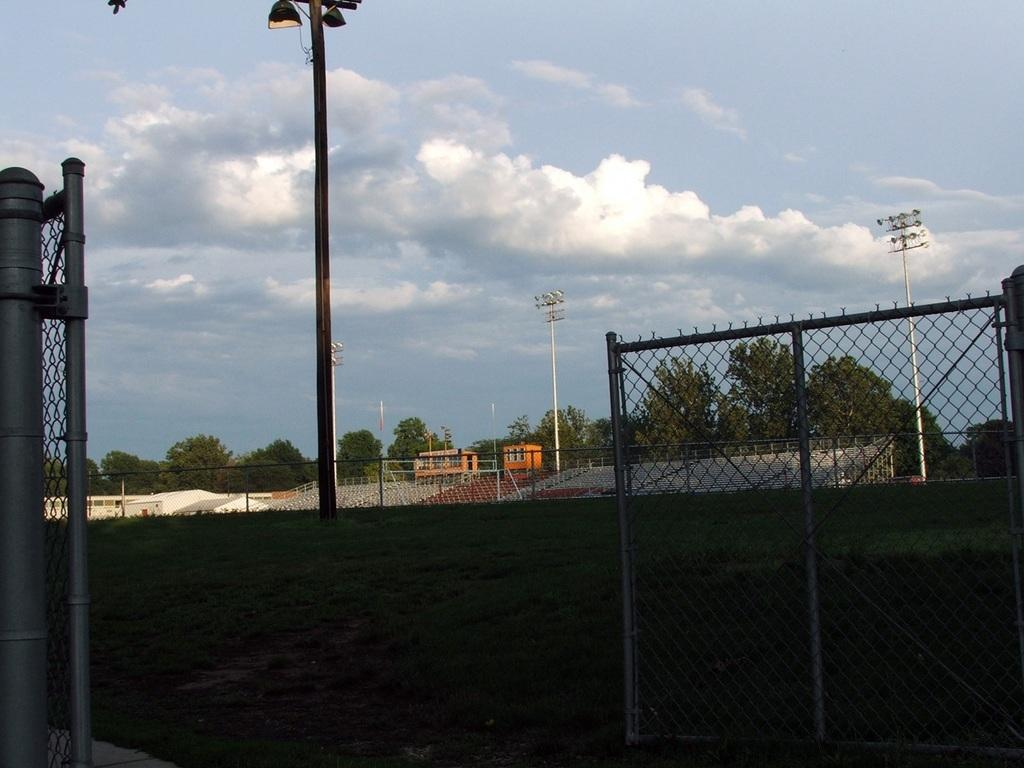What type of location is depicted in the image? The image appears to be a stadium. What can be seen in the middle of the image? There is a pole, a fence, and trees in the middle of the image. What is visible at the top of the image? The sky is visible at the top of the image. What type of argument is taking place in the image? There is no argument present in the image; it depicts a stadium with a pole, a fence, trees, and the sky. What type of development is being constructed in the image? There is no construction or development visible in the image; it depicts a stadium with a pole, a fence, trees, and the sky. 